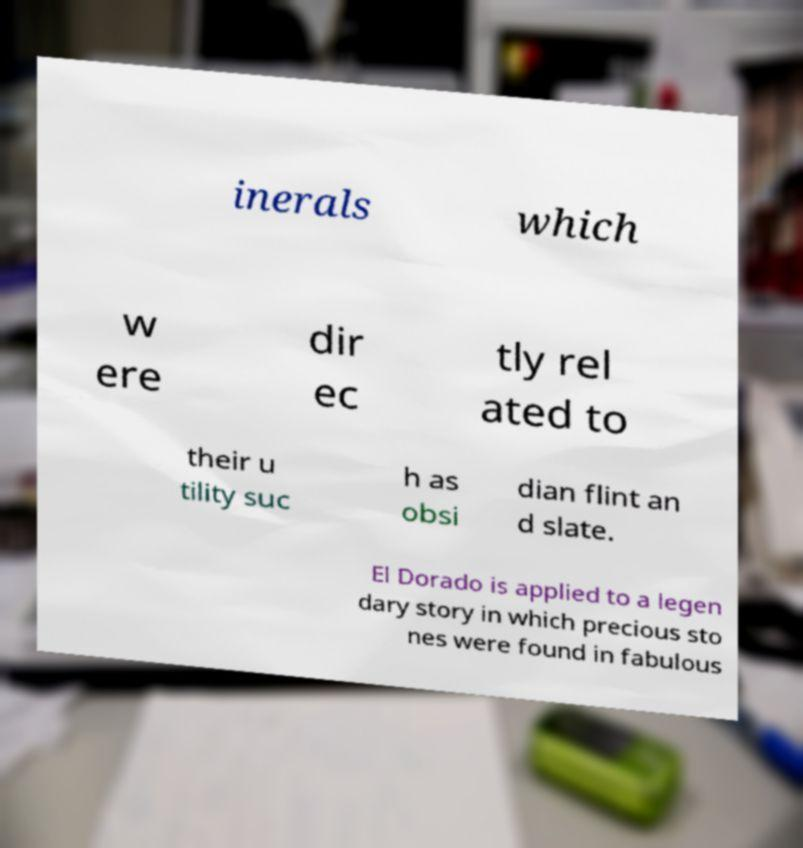Could you assist in decoding the text presented in this image and type it out clearly? inerals which w ere dir ec tly rel ated to their u tility suc h as obsi dian flint an d slate. El Dorado is applied to a legen dary story in which precious sto nes were found in fabulous 